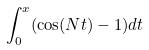<formula> <loc_0><loc_0><loc_500><loc_500>\int _ { 0 } ^ { x } ( \cos ( N t ) - 1 ) d t</formula> 